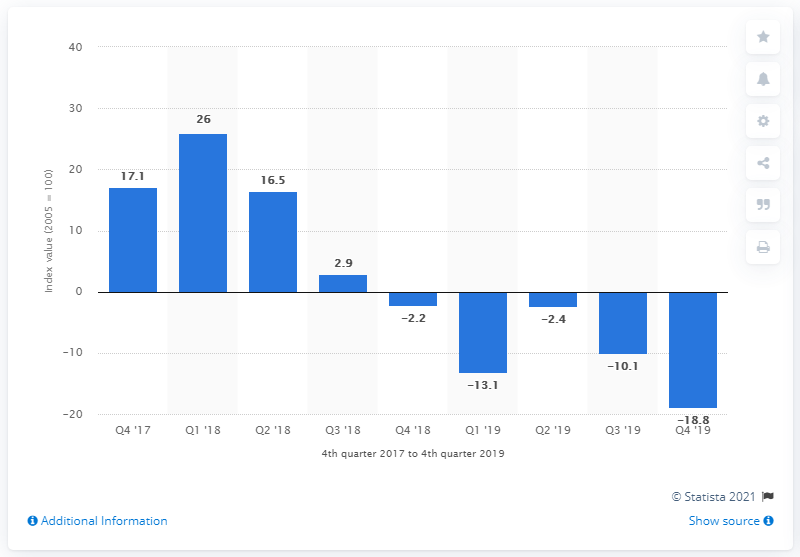Draw attention to some important aspects in this diagram. The IFo World Economic Climate Index in the fourth quarter of 2019 was -18.8, indicating a deterioration in global economic conditions compared to the previous quarter. 